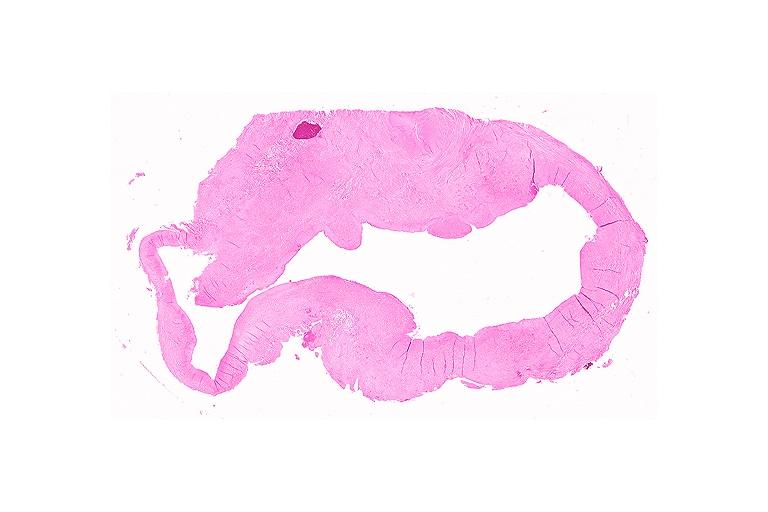does unopened larynx seen from above edema show cyst?
Answer the question using a single word or phrase. No 